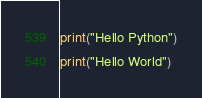<code> <loc_0><loc_0><loc_500><loc_500><_Python_>print("Hello Python")
print("Hello World")
</code> 